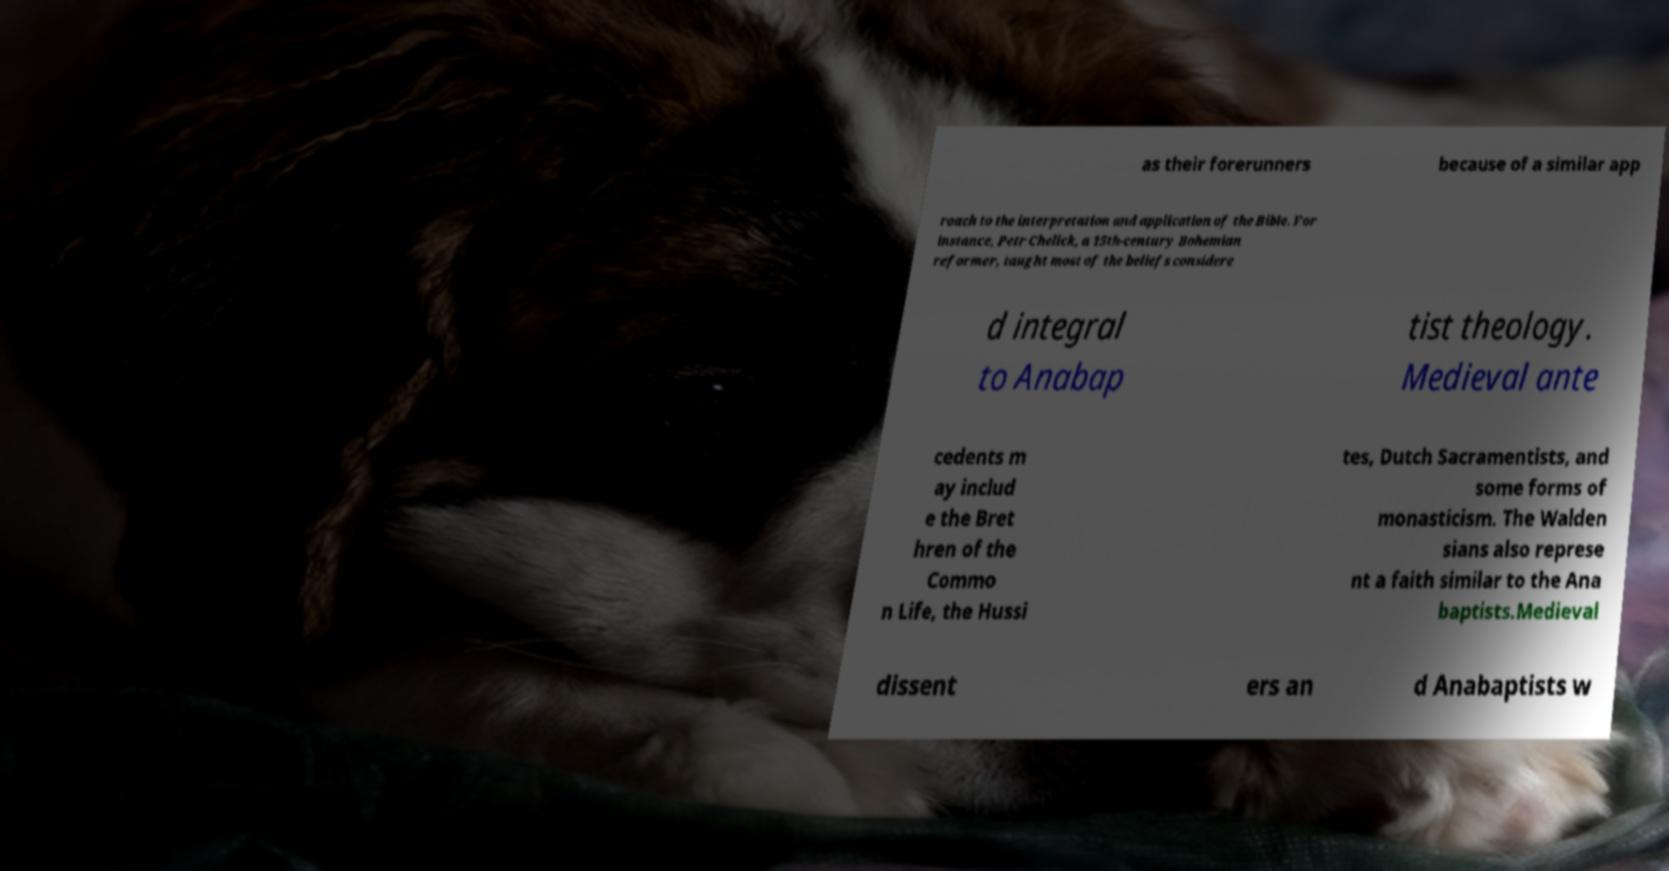There's text embedded in this image that I need extracted. Can you transcribe it verbatim? as their forerunners because of a similar app roach to the interpretation and application of the Bible. For instance, Petr Chelick, a 15th-century Bohemian reformer, taught most of the beliefs considere d integral to Anabap tist theology. Medieval ante cedents m ay includ e the Bret hren of the Commo n Life, the Hussi tes, Dutch Sacramentists, and some forms of monasticism. The Walden sians also represe nt a faith similar to the Ana baptists.Medieval dissent ers an d Anabaptists w 